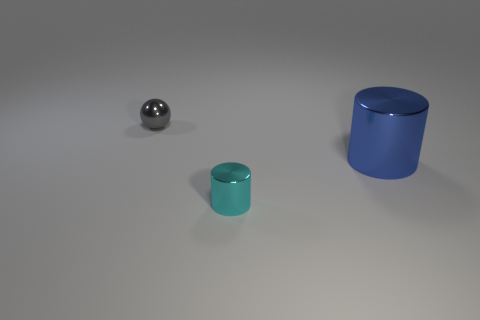What materials do the objects in the image appear to be made of? The objects in the image seem to have metallic surfaces, given their shiny and reflective qualities. 